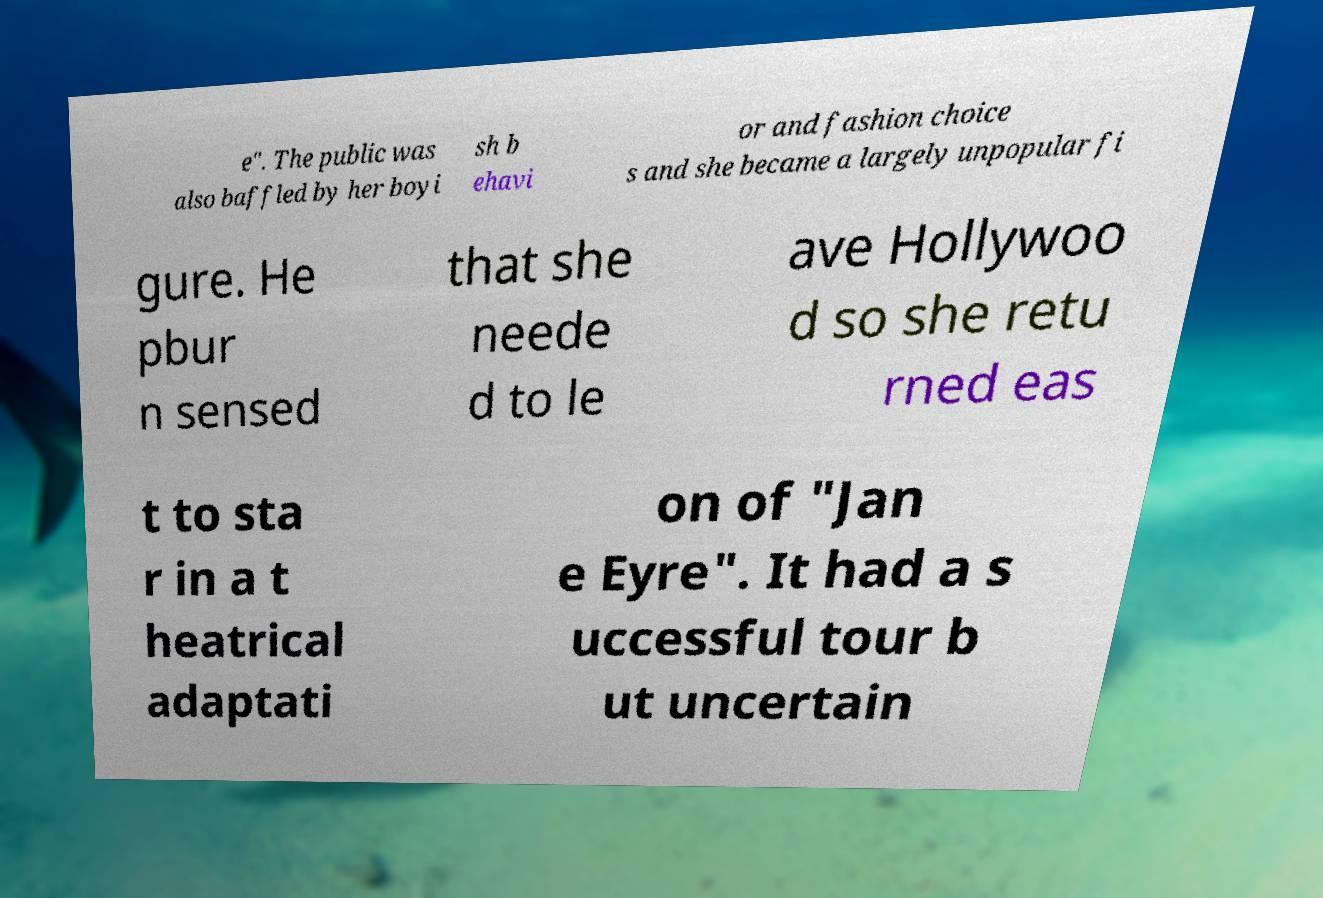Can you accurately transcribe the text from the provided image for me? e". The public was also baffled by her boyi sh b ehavi or and fashion choice s and she became a largely unpopular fi gure. He pbur n sensed that she neede d to le ave Hollywoo d so she retu rned eas t to sta r in a t heatrical adaptati on of "Jan e Eyre". It had a s uccessful tour b ut uncertain 